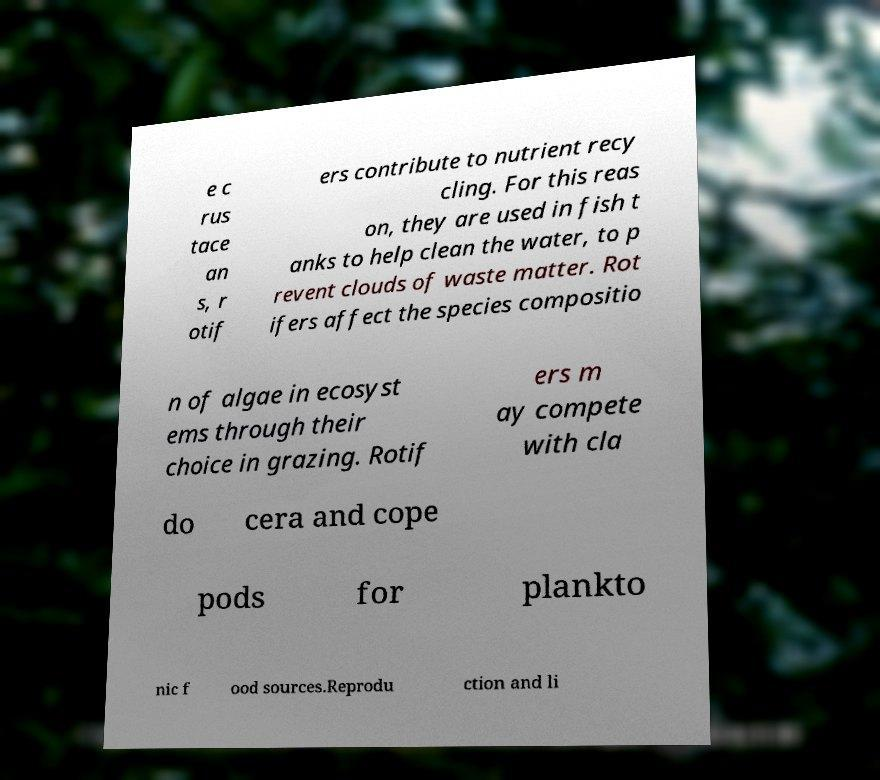Please read and relay the text visible in this image. What does it say? e c rus tace an s, r otif ers contribute to nutrient recy cling. For this reas on, they are used in fish t anks to help clean the water, to p revent clouds of waste matter. Rot ifers affect the species compositio n of algae in ecosyst ems through their choice in grazing. Rotif ers m ay compete with cla do cera and cope pods for plankto nic f ood sources.Reprodu ction and li 